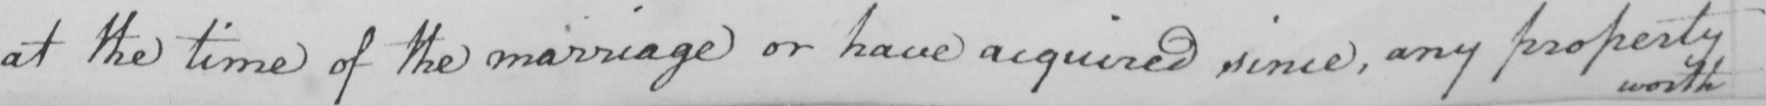Please transcribe the handwritten text in this image. at the time of the marriage or have acquired since , any property 